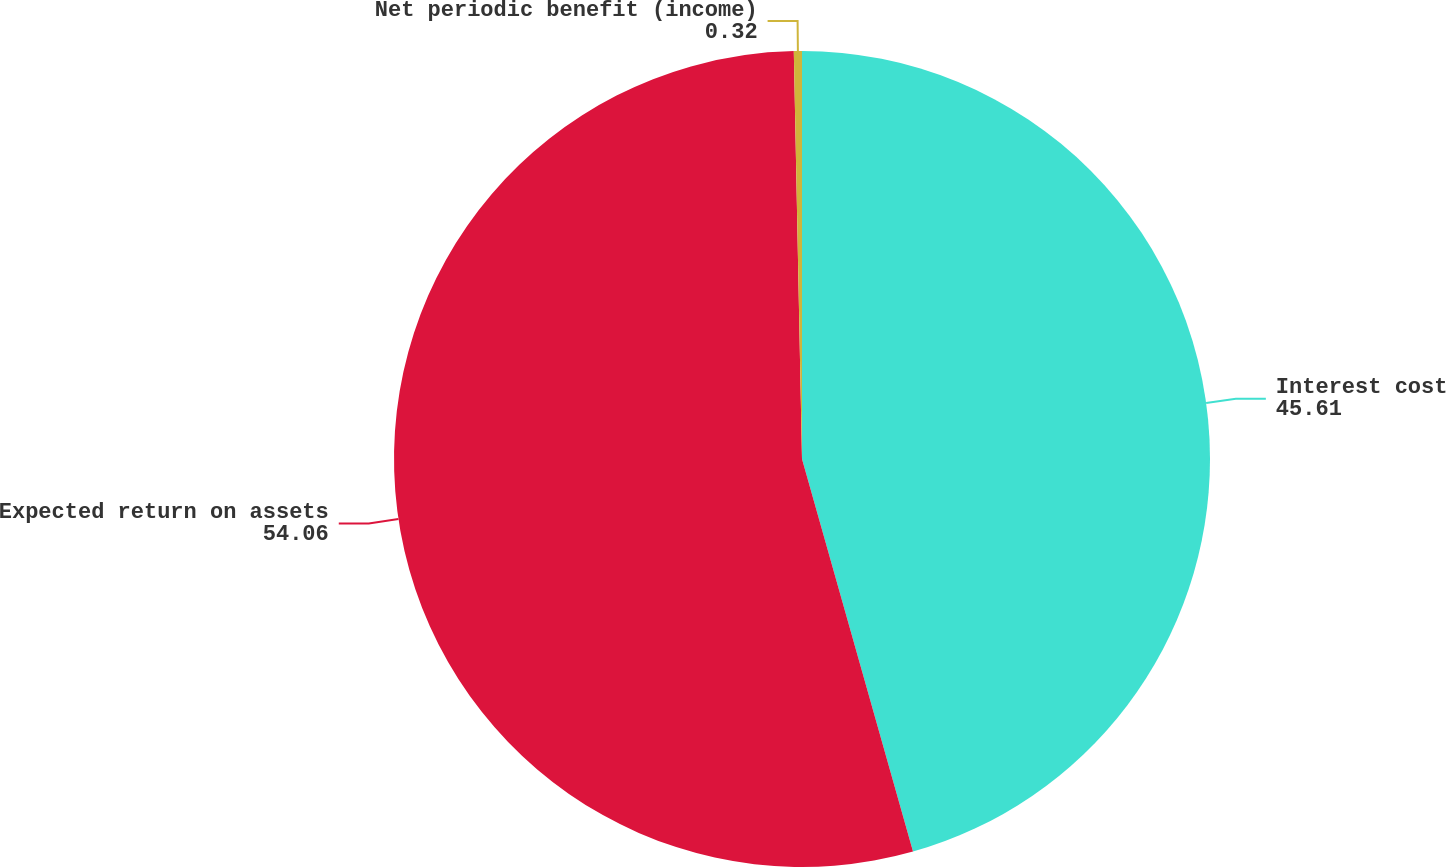Convert chart. <chart><loc_0><loc_0><loc_500><loc_500><pie_chart><fcel>Interest cost<fcel>Expected return on assets<fcel>Net periodic benefit (income)<nl><fcel>45.61%<fcel>54.06%<fcel>0.32%<nl></chart> 